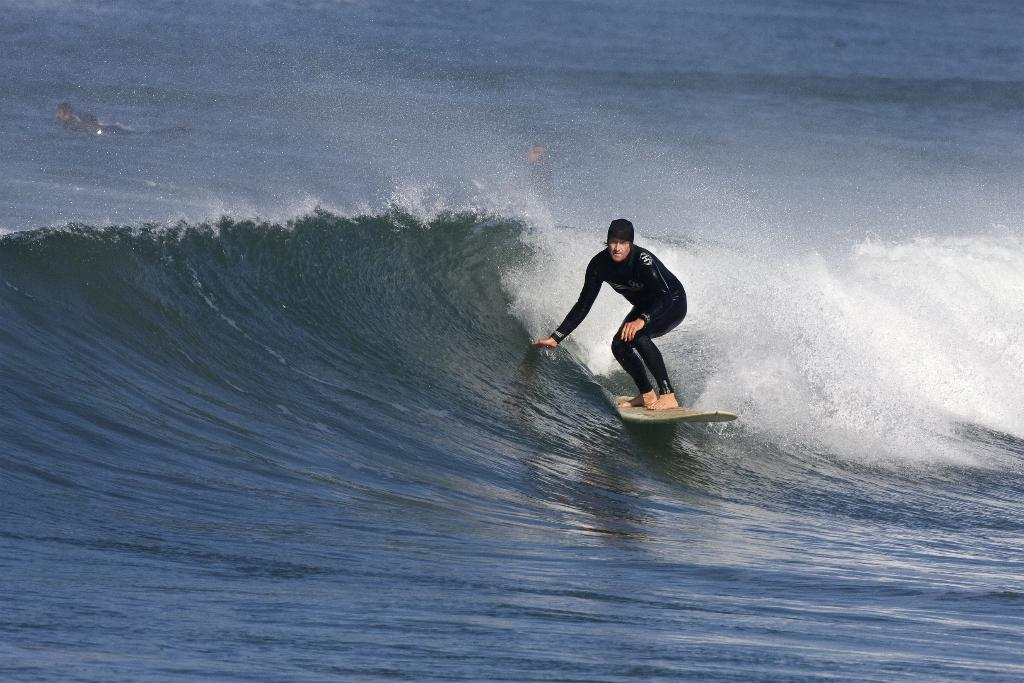What is happening in the image? There is a person in the image who is surfing on the water. Can you describe the activity the person is engaged in? The person is surfing, which involves riding a surfboard on the water. How many women are present in the image? There is no mention of women in the image, as it only features a person surfing on the water. What shape is the surfboard in the image? The provided facts do not mention the shape of the surfboard, so it cannot be determined from the image. 